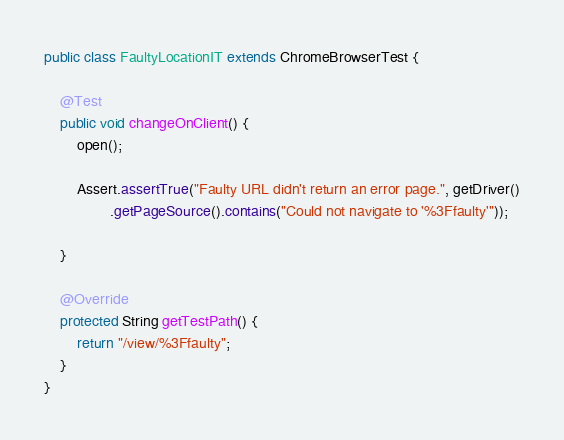Convert code to text. <code><loc_0><loc_0><loc_500><loc_500><_Java_>
public class FaultyLocationIT extends ChromeBrowserTest {

    @Test
    public void changeOnClient() {
        open();

        Assert.assertTrue("Faulty URL didn't return an error page.", getDriver()
                .getPageSource().contains("Could not navigate to '%3Ffaulty'"));

    }

    @Override
    protected String getTestPath() {
        return "/view/%3Ffaulty";
    }
}
</code> 